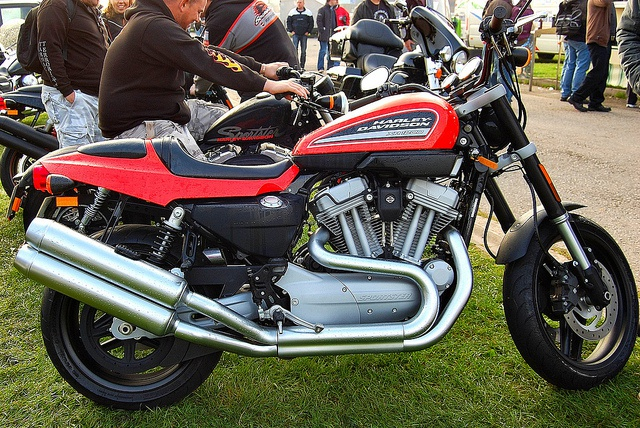Describe the objects in this image and their specific colors. I can see motorcycle in lavender, black, white, gray, and darkgray tones, people in lavender, black, gray, darkgray, and maroon tones, people in lavender, black, darkgray, and gray tones, motorcycle in lavender, black, gray, ivory, and darkgray tones, and people in lavender, black, gray, darkgray, and maroon tones in this image. 